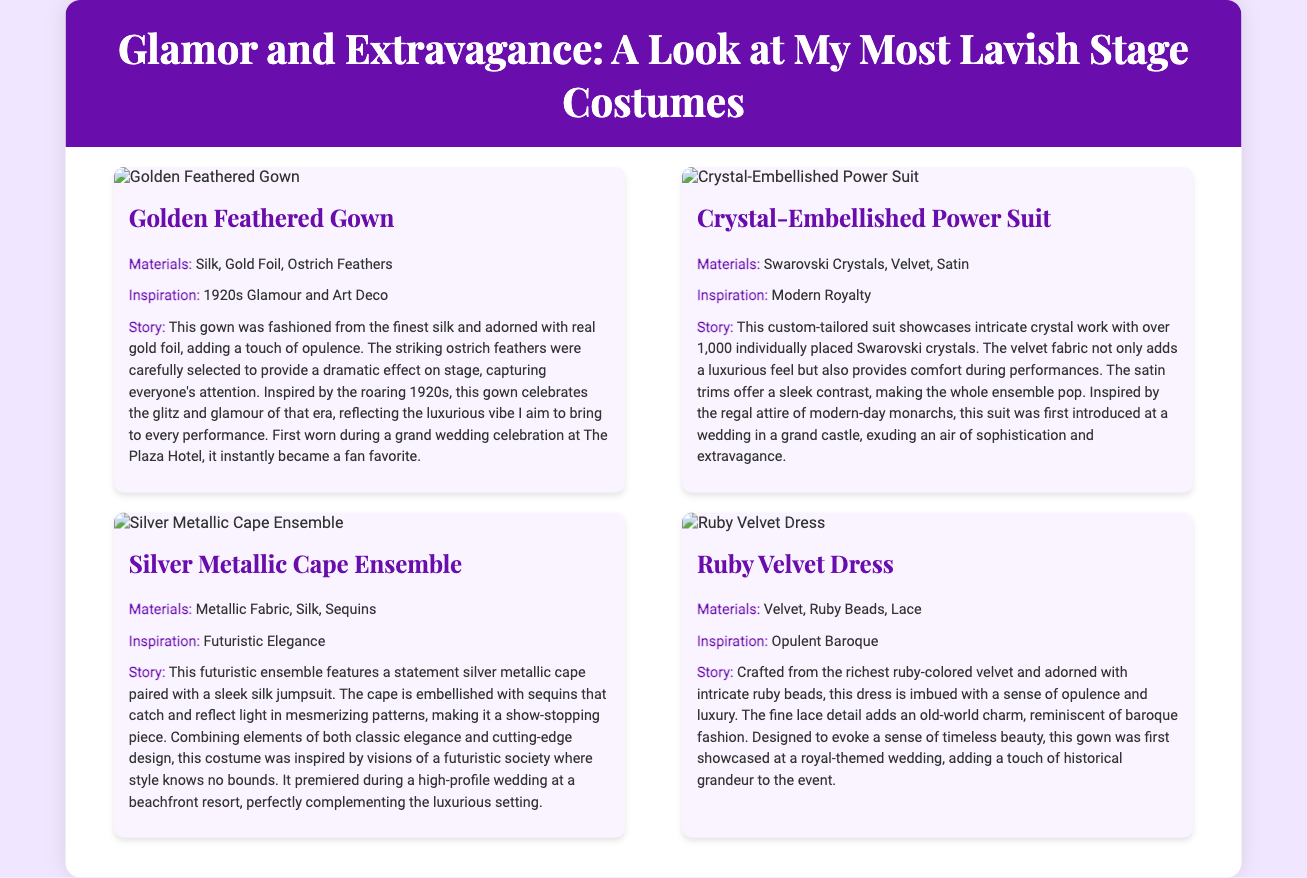What is the name of the first costume featured? The first costume listed in the document is titled "Golden Feathered Gown."
Answer: Golden Feathered Gown How many Swarovski crystals are used in the Power Suit? The document states that the Power Suit features over 1,000 individually placed Swarovski crystals.
Answer: Over 1,000 What is the main color of the Ruby Velvet Dress? The Ruby Velvet Dress is described as being crafted from ruby-colored velvet.
Answer: Ruby Which material is common among the costumes? All costumes share the use of luxurious and high-quality materials like silk, velvet, or sequins.
Answer: Silk, Velvet, Sequins What wedding venue is mentioned for the Golden Feathered Gown? The Golden Feathered Gown was first worn during a grand wedding celebration at The Plaza Hotel.
Answer: The Plaza Hotel What era does the Golden Feathered Gown draw inspiration from? The inspiration for the Golden Feathered Gown is said to come from the roaring 1920s.
Answer: 1920s Which costume features a metallic fabric? The Silver Metallic Cape Ensemble prominently features metallic fabric.
Answer: Silver Metallic Cape Ensemble What theme inspired the Ruby Velvet Dress? The Ruby Velvet Dress is inspired by opulent Baroque fashion.
Answer: Opulent Baroque 